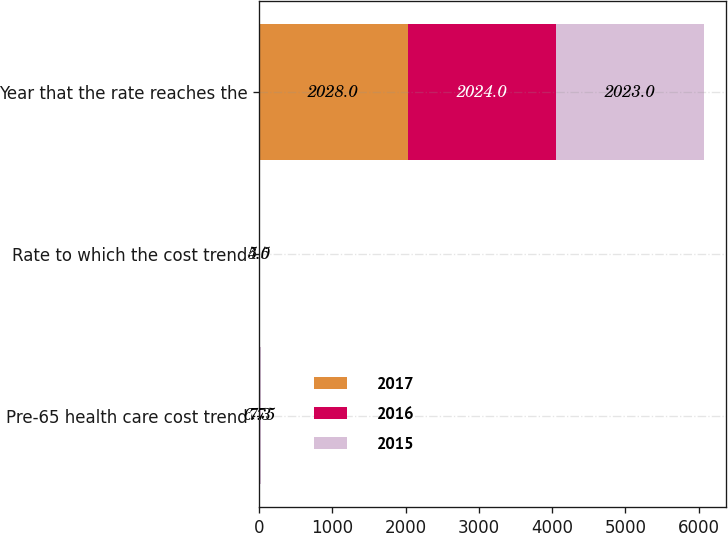Convert chart. <chart><loc_0><loc_0><loc_500><loc_500><stacked_bar_chart><ecel><fcel>Pre-65 health care cost trend<fcel>Rate to which the cost trend<fcel>Year that the rate reaches the<nl><fcel>2017<fcel>6.75<fcel>4.5<fcel>2028<nl><fcel>2016<fcel>6.9<fcel>5<fcel>2024<nl><fcel>2015<fcel>7.3<fcel>5<fcel>2023<nl></chart> 